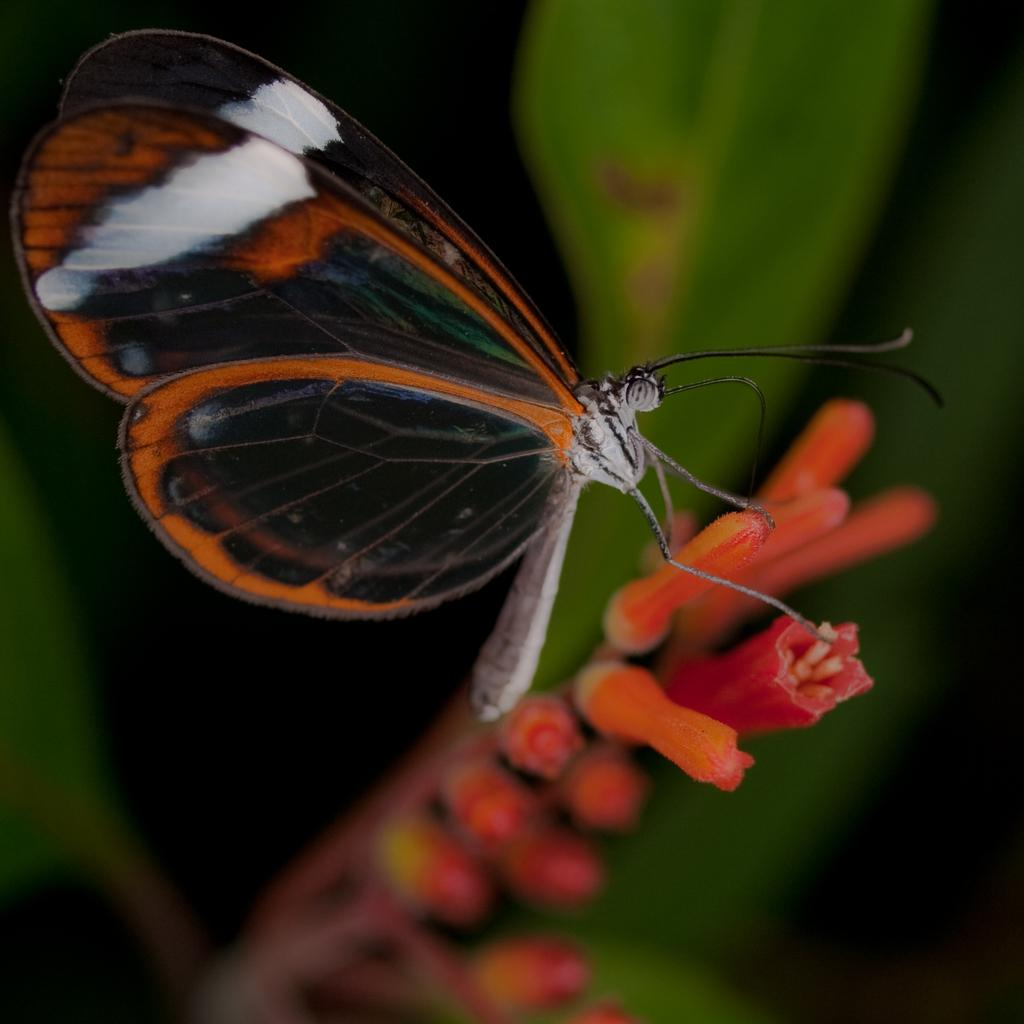What is the main subject in the center of the image? There is a flower in the center of the image. Is there anything on the flower? Yes, there is a butterfly on the flower. What type of pet can be seen crying in the image? There is no pet or crying in the image; it features a flower with a butterfly on it. What type of nail is being used to paint the flower in the image? There is no nail or painting activity in the image; it features a flower with a butterfly on it. 